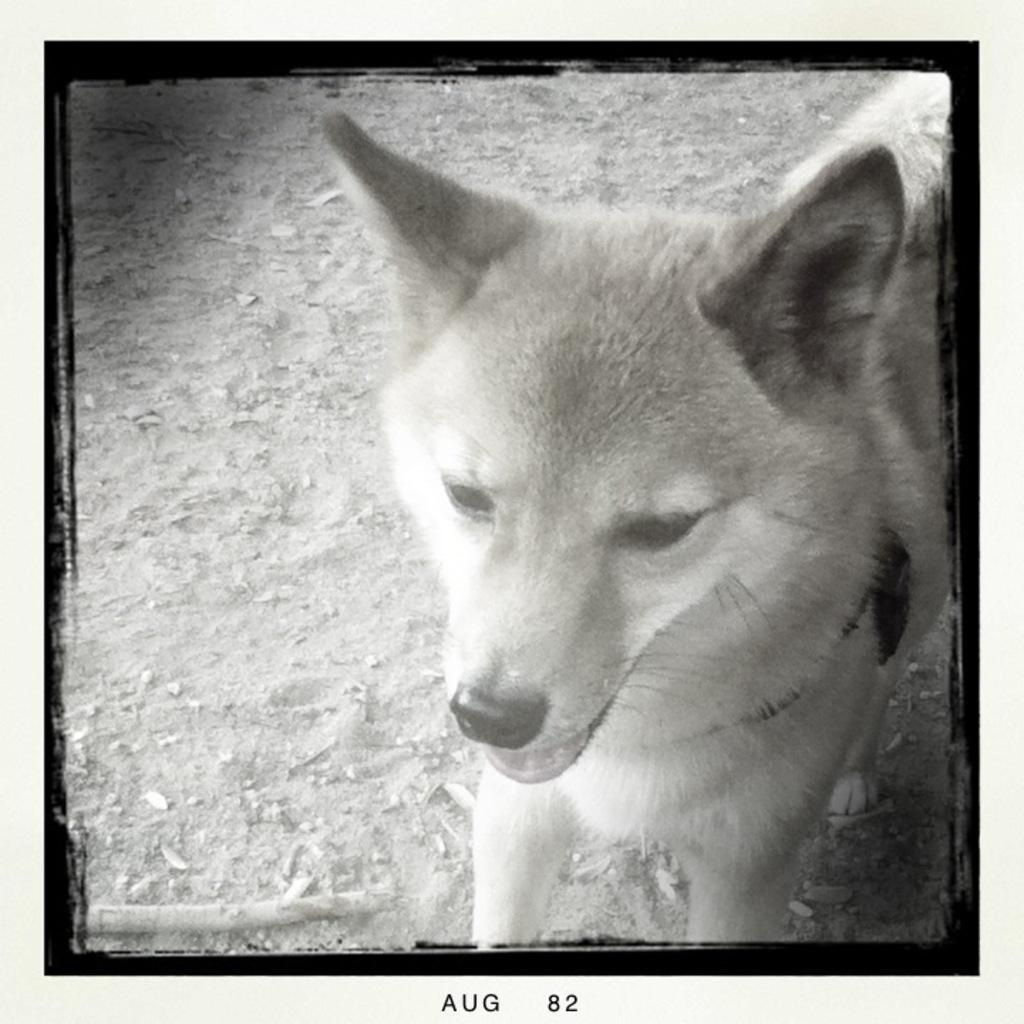What type of animal is present in the image? There is a dog in the image. What type of border is visible in the image? There is no border present in the image; it features a dog. What is the tax rate for the dog in the image? There is no tax rate mentioned in the image, as it only features a dog. 